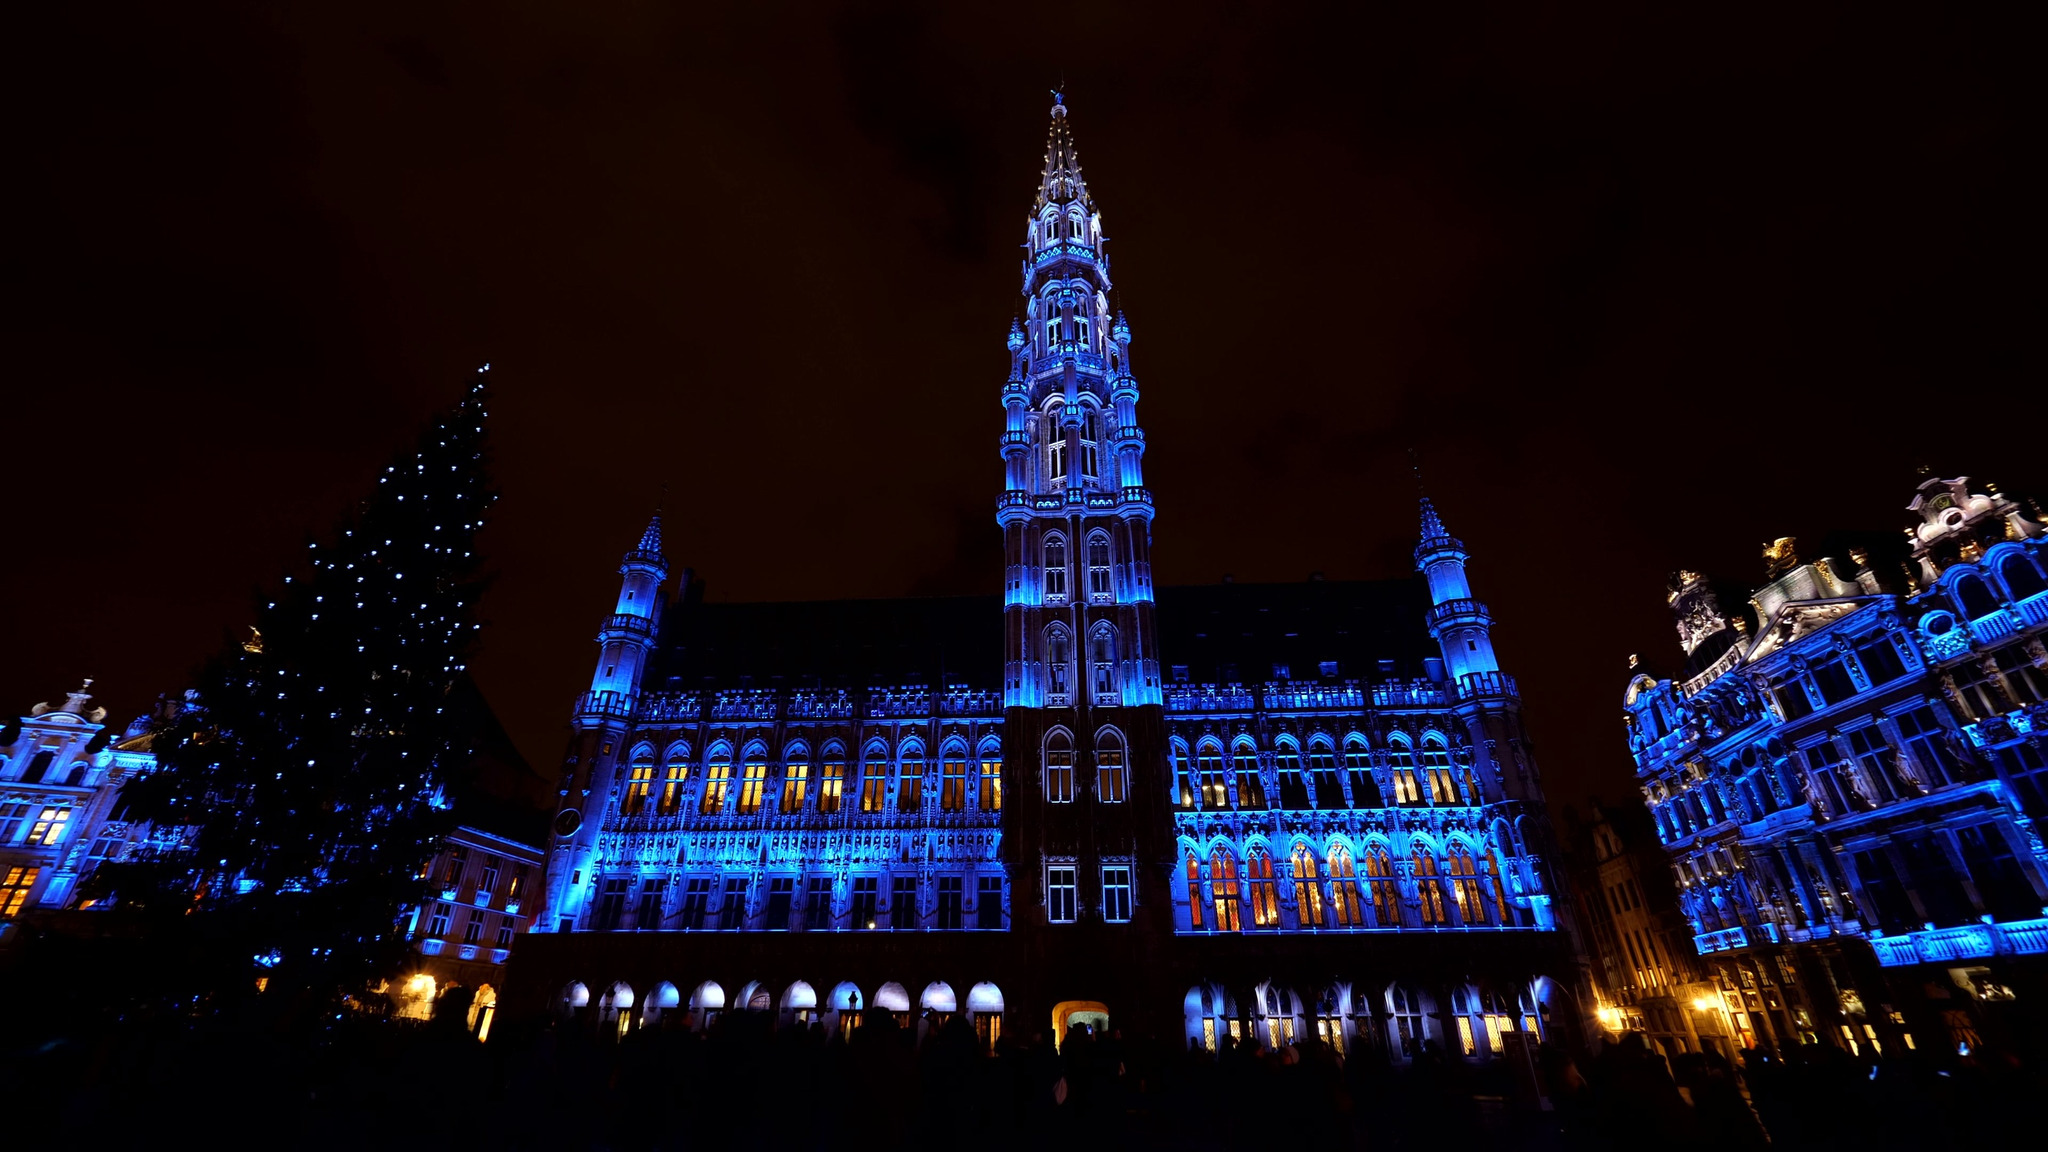What is the history behind the Brussels Town Hall? The Brussels Town Hall, or Hôtel de Ville, is a splendid example of Gothic architecture, completed in the 15th century. Its construction began in 1402 and was finished in 1455, serving as a symbol of the city's wealth and power during the medieval period. The building has faced various challenges, including damages from wars and natural wear over the centuries, but it has been meticulously restored to preserve its historical significance. The central spire, a prominent feature of the Town Hall, was added later by architect Jan van Ruysbroek. This iconic structure is not only a key administrative building but also serves as a venue for various civic events and ceremonies, representing the vibrant cultural heritage of Brussels. How does the Grand Place look during festivals? During festivals, the Grand Place transforms into a spectacular and lively arena. The square is adorned with elaborate decorations, vibrant lights, and often features themed installations. One of the most famous events is the Brussels Flower Carpet, where every two years, thousands of begonias are arranged in a massive, intricate floral design that covers the entire square. Christmas is another special time, with a towering Christmas tree, a festive light show, and a cozy Christmas market adding to the charm. The square becomes a hub of activity, filled with tourists and locals alike, enjoying cultural performances, food stalls, and the general festive spirit that encapsulates the rich traditions of Brussels. Can you describe a typical day in the Grand Place for a visitor? A typical day for a visitor in the Grand Place often begins with a morning stroll through the cobblestone streets, taking in the breathtaking architecture of the surrounding buildings. They might start with a guided tour of the Town Hall to learn about its rich history and intricate design. Afterwards, a visit to one of the numerous cafes around the square for a Brussels waffle or a cup of Belgian coffee is a must. The afternoon could be spent exploring the nearby Galeries Royales Saint-Hubert, an elegant shopping arcade, or visiting one of the many museums that dot the area, such as the Museum of the City of Brussels which offers insights into the city’s fascinating history. As the evening approaches, the Grand Place truly comes alive with street performances, musicians, and artists showcasing their talents. Dining at one of the local restaurants, savoring authentic Belgian cuisine like moules-frites (mussels and fries) or indulging in a thick Belgian beer, rounds off the day splendidly. The atmosphere is one of vibrant energy, cultural richness, and timeless beauty, emblematic of Brussels' spirit. 